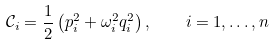Convert formula to latex. <formula><loc_0><loc_0><loc_500><loc_500>\mathcal { C } _ { i } = \frac { 1 } { 2 } \left ( p _ { i } ^ { 2 } + \omega _ { i } ^ { 2 } q _ { i } ^ { 2 } \right ) , \quad i = 1 , \dots , n</formula> 